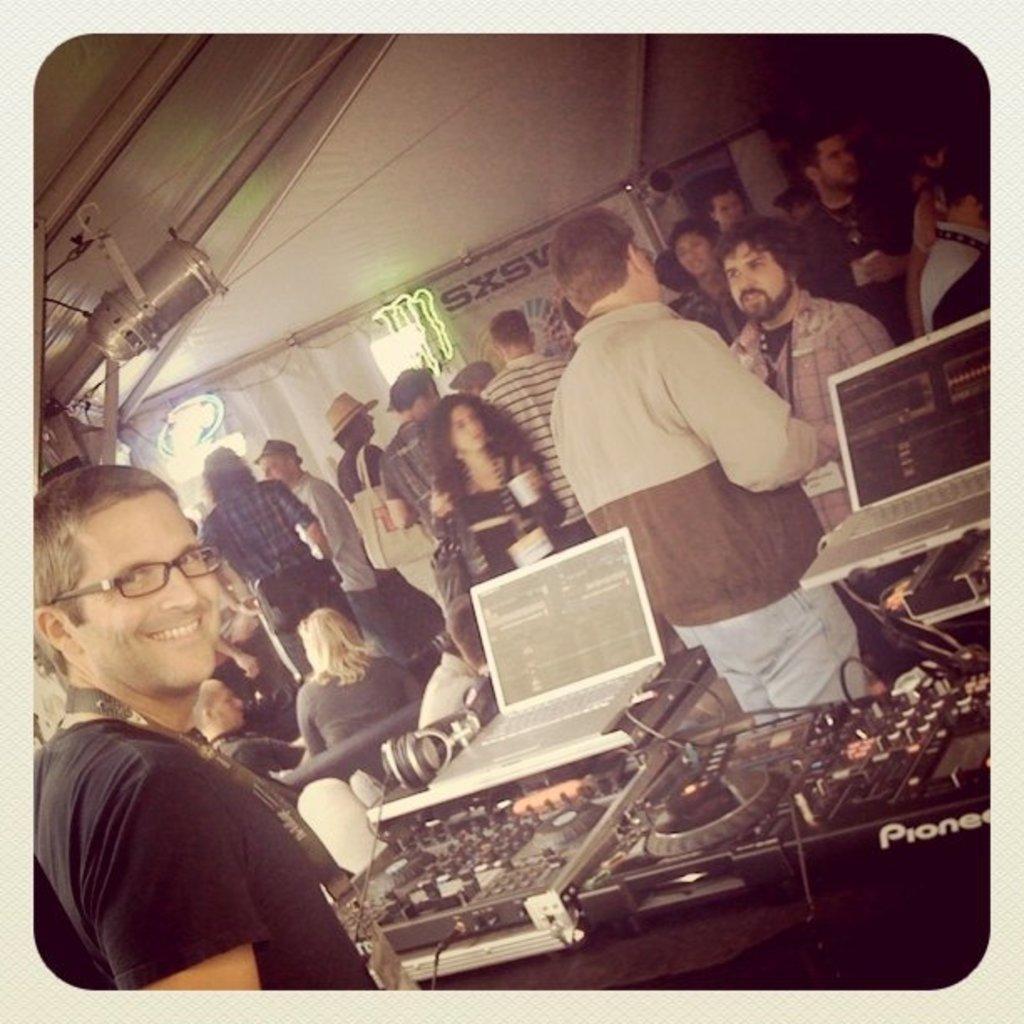In one or two sentences, can you explain what this image depicts? In this image we can see a few people standing, a person is holding an object, two people are sitting on a couch and there are laptops and music players. 